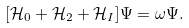<formula> <loc_0><loc_0><loc_500><loc_500>[ \mathcal { H } _ { 0 } + \mathcal { H } _ { 2 } + \mathcal { H } _ { I } ] \Psi = \omega \Psi .</formula> 